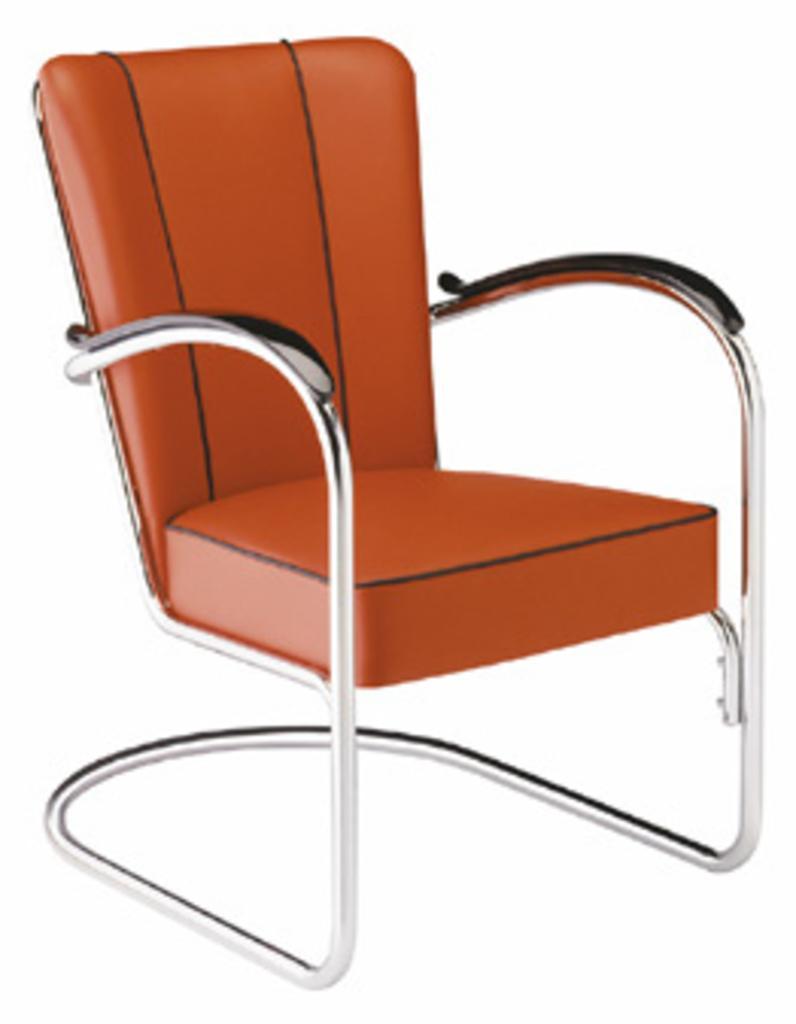Please provide a concise description of this image. There is a chair with brown seat, wooden handle and steel legs. 